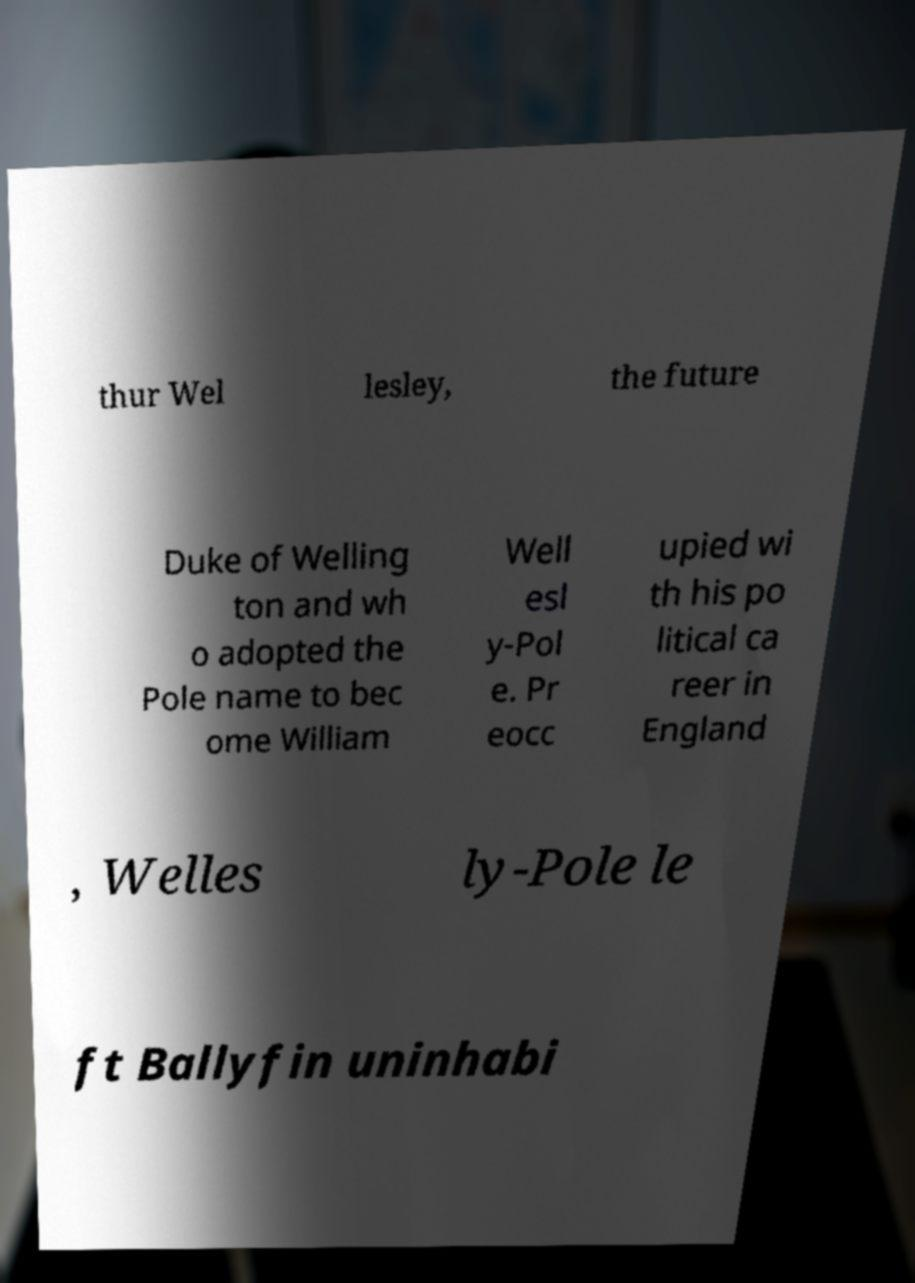Can you accurately transcribe the text from the provided image for me? thur Wel lesley, the future Duke of Welling ton and wh o adopted the Pole name to bec ome William Well esl y-Pol e. Pr eocc upied wi th his po litical ca reer in England , Welles ly-Pole le ft Ballyfin uninhabi 